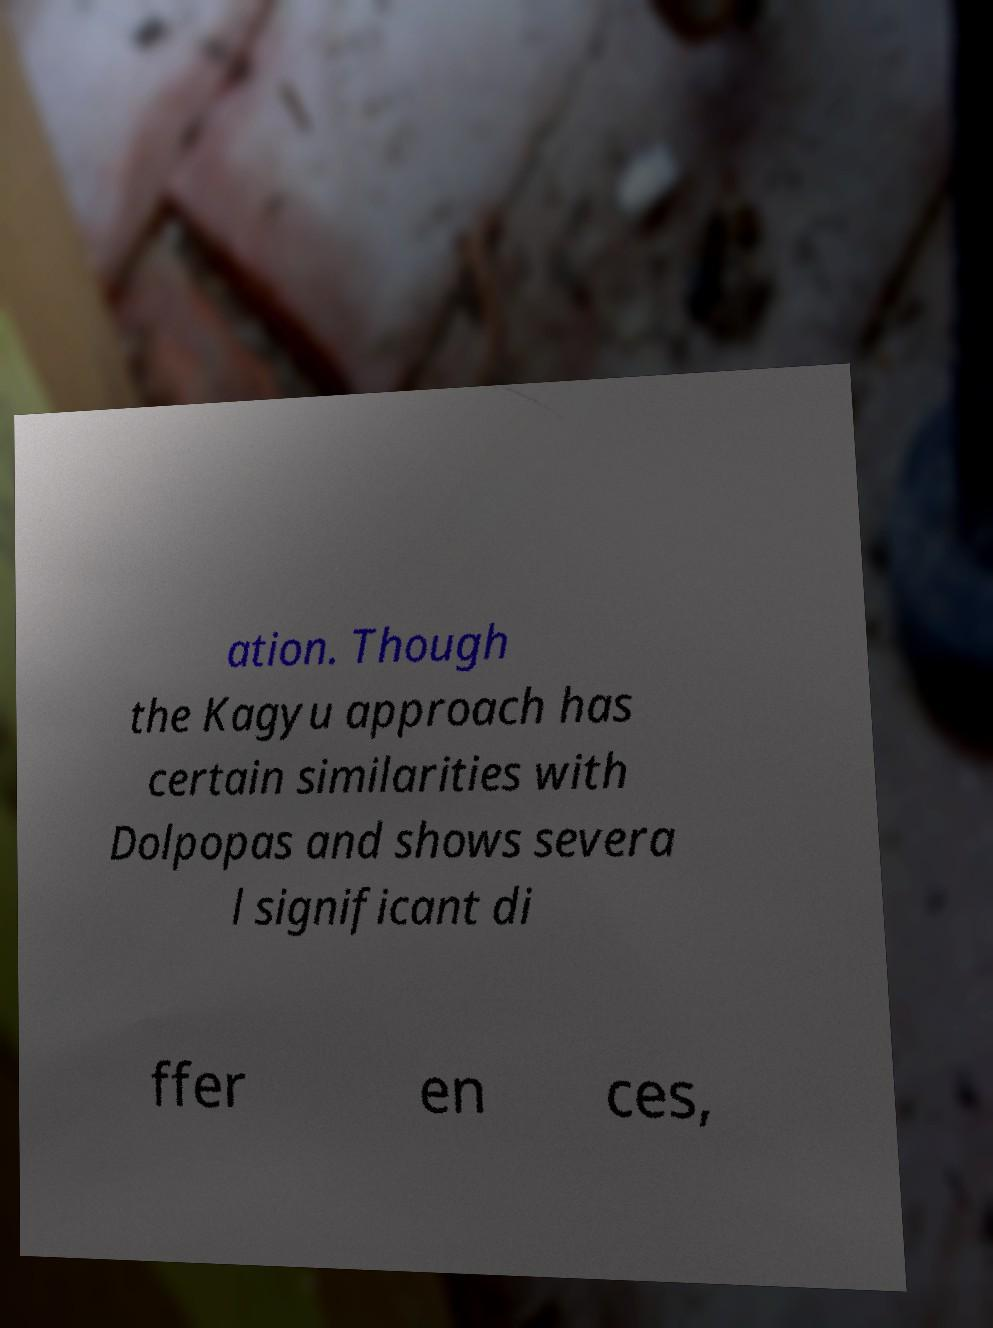Could you extract and type out the text from this image? ation. Though the Kagyu approach has certain similarities with Dolpopas and shows severa l significant di ffer en ces, 